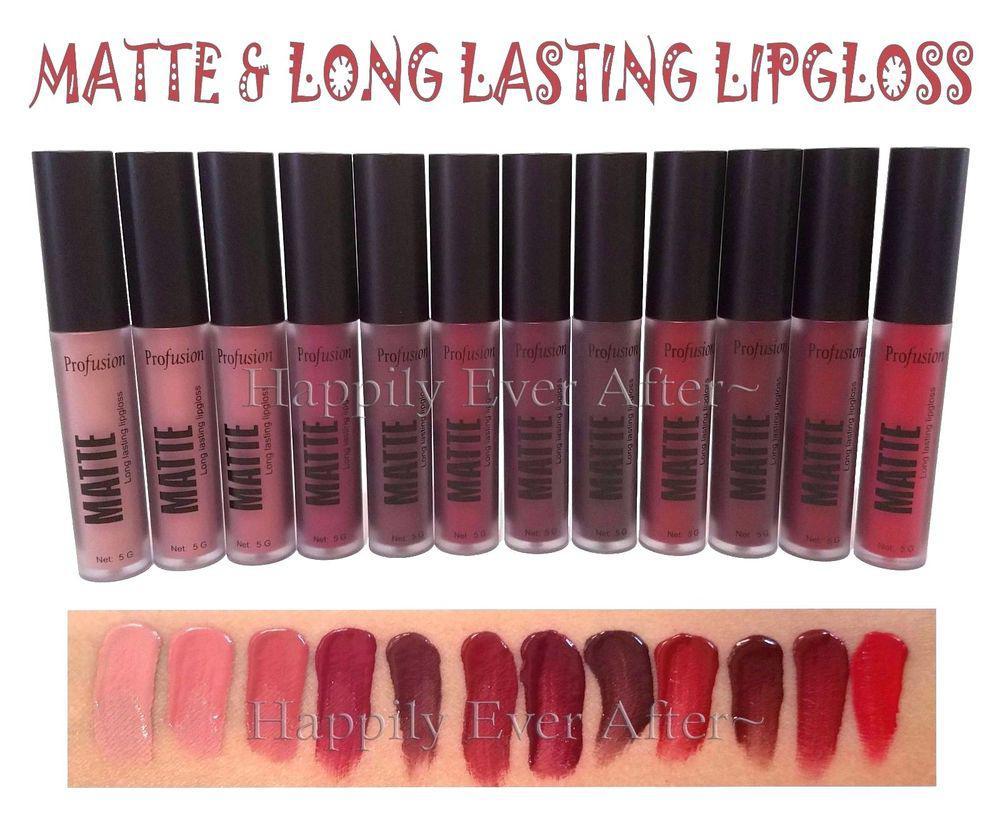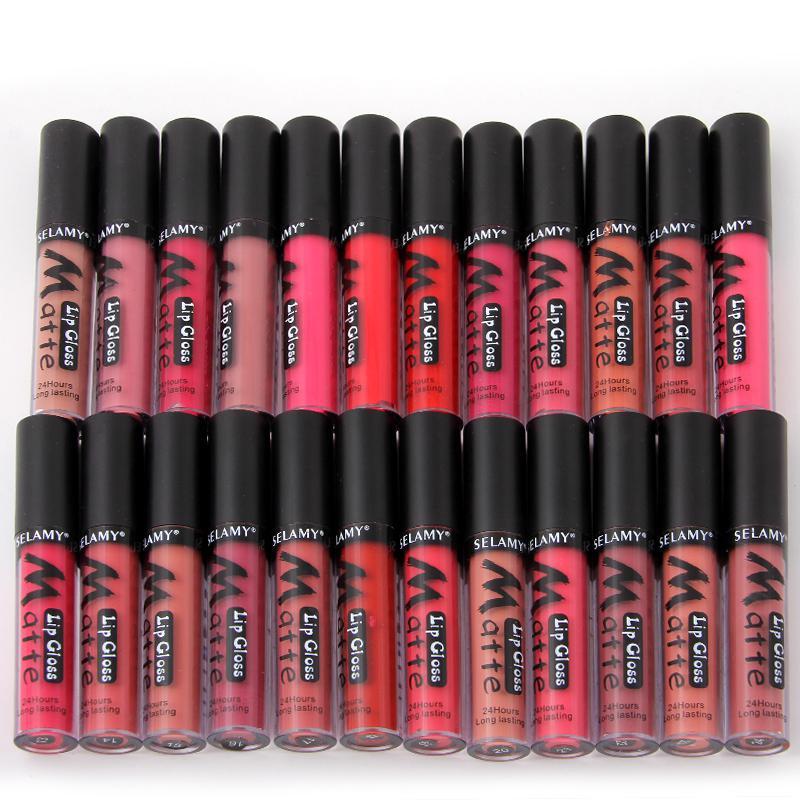The first image is the image on the left, the second image is the image on the right. Assess this claim about the two images: "Right image shows two horizontal rows of the same product style.". Correct or not? Answer yes or no. Yes. The first image is the image on the left, the second image is the image on the right. Assess this claim about the two images: "There are at least eleven lipsticks in the image on the left.". Correct or not? Answer yes or no. Yes. 